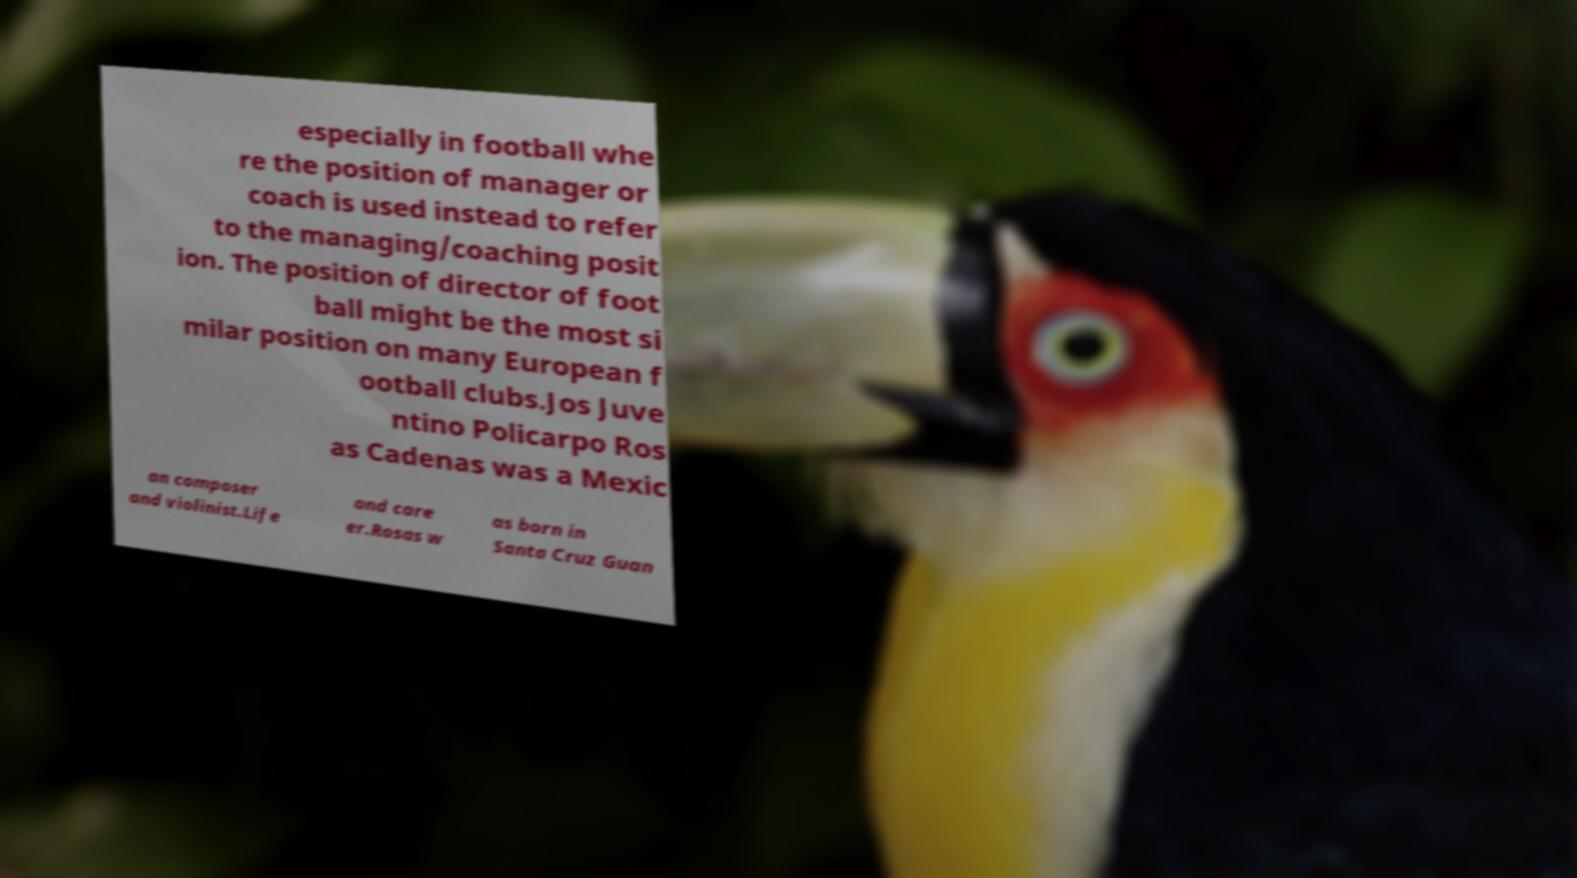I need the written content from this picture converted into text. Can you do that? especially in football whe re the position of manager or coach is used instead to refer to the managing/coaching posit ion. The position of director of foot ball might be the most si milar position on many European f ootball clubs.Jos Juve ntino Policarpo Ros as Cadenas was a Mexic an composer and violinist.Life and care er.Rosas w as born in Santa Cruz Guan 